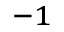<formula> <loc_0><loc_0><loc_500><loc_500>^ { - 1 }</formula> 